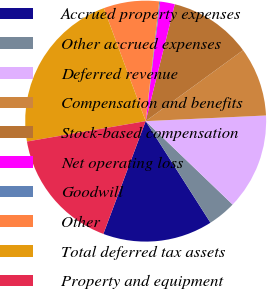Convert chart to OTSL. <chart><loc_0><loc_0><loc_500><loc_500><pie_chart><fcel>Accrued property expenses<fcel>Other accrued expenses<fcel>Deferred revenue<fcel>Compensation and benefits<fcel>Stock-based compensation<fcel>Net operating loss<fcel>Goodwill<fcel>Other<fcel>Total deferred tax assets<fcel>Property and equipment<nl><fcel>14.75%<fcel>3.79%<fcel>12.92%<fcel>9.27%<fcel>11.1%<fcel>1.96%<fcel>0.13%<fcel>7.44%<fcel>22.06%<fcel>16.58%<nl></chart> 